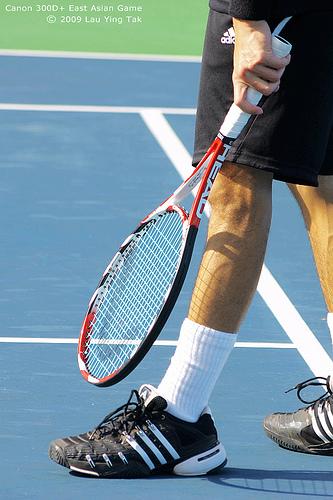What color socks is this person wearing?
Give a very brief answer. White. What color are his shoes?
Concise answer only. Black and white. What is likely the players dominant hand?
Give a very brief answer. Left. 